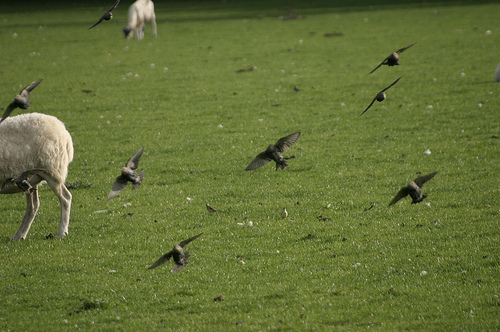Please provide a short description for this region: [0.31, 0.63, 0.43, 0.76]. This region shows a bird close to the green grass, likely preparing for landing with its wings slightly raised. 